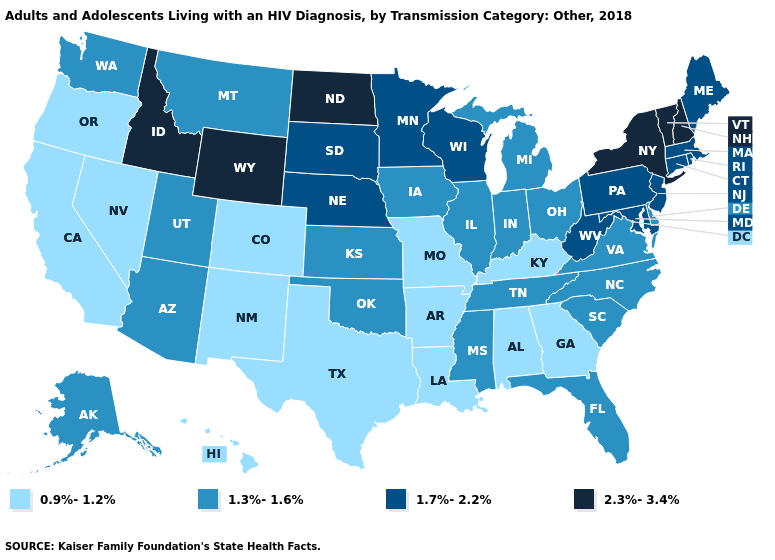How many symbols are there in the legend?
Be succinct. 4. What is the value of Illinois?
Quick response, please. 1.3%-1.6%. What is the value of Idaho?
Answer briefly. 2.3%-3.4%. What is the value of Alabama?
Concise answer only. 0.9%-1.2%. Name the states that have a value in the range 1.7%-2.2%?
Be succinct. Connecticut, Maine, Maryland, Massachusetts, Minnesota, Nebraska, New Jersey, Pennsylvania, Rhode Island, South Dakota, West Virginia, Wisconsin. Among the states that border Massachusetts , does Connecticut have the highest value?
Short answer required. No. Does the map have missing data?
Concise answer only. No. What is the highest value in the USA?
Answer briefly. 2.3%-3.4%. Name the states that have a value in the range 0.9%-1.2%?
Give a very brief answer. Alabama, Arkansas, California, Colorado, Georgia, Hawaii, Kentucky, Louisiana, Missouri, Nevada, New Mexico, Oregon, Texas. What is the highest value in the West ?
Keep it brief. 2.3%-3.4%. What is the lowest value in the West?
Short answer required. 0.9%-1.2%. Which states have the highest value in the USA?
Give a very brief answer. Idaho, New Hampshire, New York, North Dakota, Vermont, Wyoming. Name the states that have a value in the range 1.7%-2.2%?
Give a very brief answer. Connecticut, Maine, Maryland, Massachusetts, Minnesota, Nebraska, New Jersey, Pennsylvania, Rhode Island, South Dakota, West Virginia, Wisconsin. Name the states that have a value in the range 1.3%-1.6%?
Write a very short answer. Alaska, Arizona, Delaware, Florida, Illinois, Indiana, Iowa, Kansas, Michigan, Mississippi, Montana, North Carolina, Ohio, Oklahoma, South Carolina, Tennessee, Utah, Virginia, Washington. 